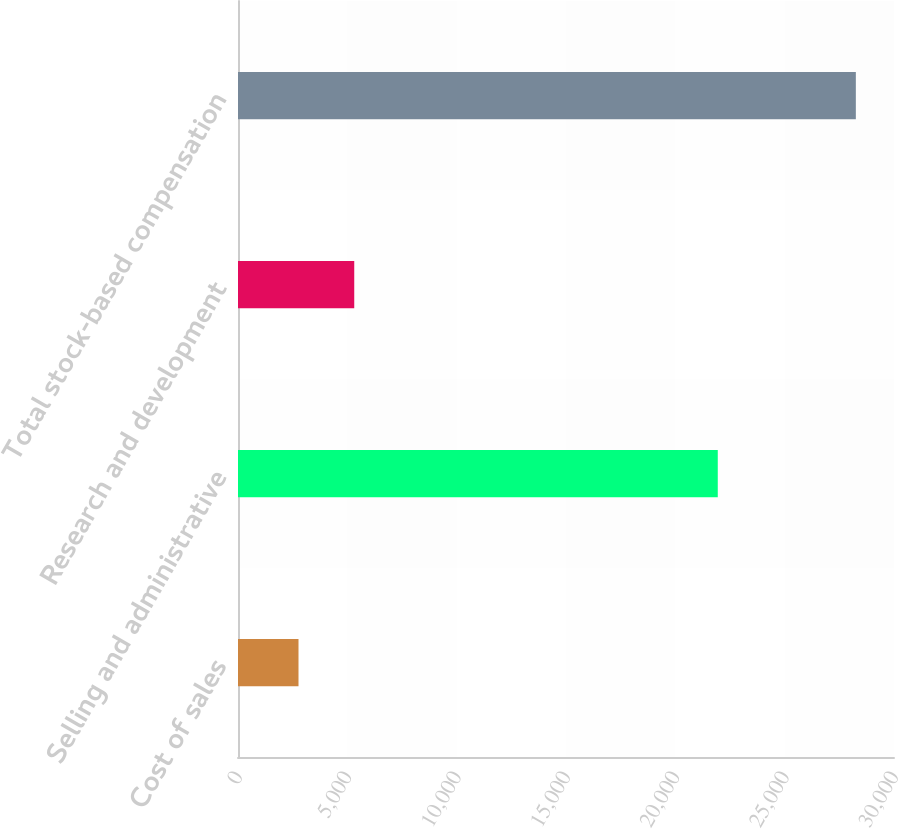<chart> <loc_0><loc_0><loc_500><loc_500><bar_chart><fcel>Cost of sales<fcel>Selling and administrative<fcel>Research and development<fcel>Total stock-based compensation<nl><fcel>2767<fcel>21941<fcel>5315.8<fcel>28255<nl></chart> 